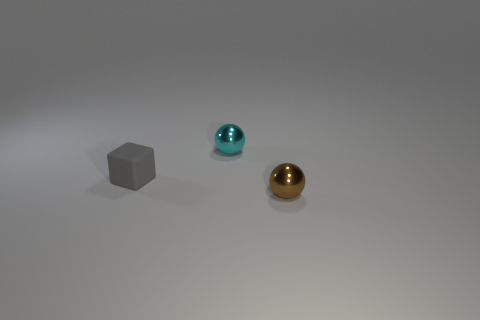Add 2 big purple matte cylinders. How many objects exist? 5 Subtract all cyan spheres. How many spheres are left? 1 Subtract all cubes. How many objects are left? 2 Subtract all yellow blocks. How many brown spheres are left? 1 Subtract 2 balls. How many balls are left? 0 Subtract all gray spheres. Subtract all green cubes. How many spheres are left? 2 Subtract all cyan metal objects. Subtract all tiny red rubber objects. How many objects are left? 2 Add 1 tiny metallic spheres. How many tiny metallic spheres are left? 3 Add 2 blue matte spheres. How many blue matte spheres exist? 2 Subtract 0 green balls. How many objects are left? 3 